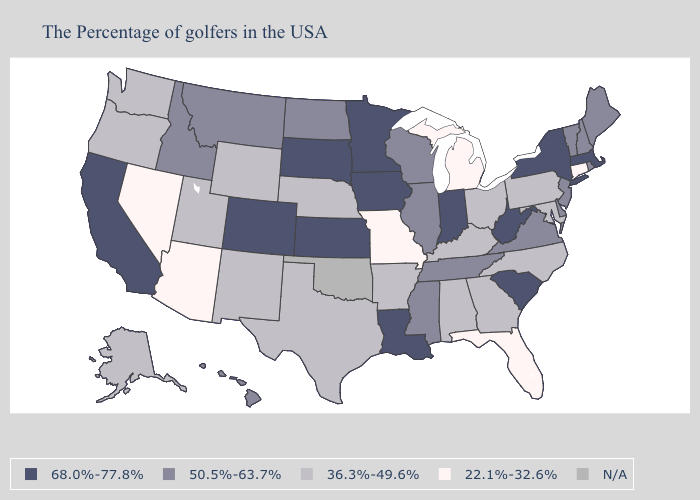Does New Mexico have the highest value in the USA?
Keep it brief. No. Does Vermont have the highest value in the Northeast?
Write a very short answer. No. Among the states that border Virginia , which have the highest value?
Quick response, please. West Virginia. Does the first symbol in the legend represent the smallest category?
Be succinct. No. What is the lowest value in the USA?
Be succinct. 22.1%-32.6%. What is the value of Wyoming?
Keep it brief. 36.3%-49.6%. Is the legend a continuous bar?
Short answer required. No. What is the lowest value in the USA?
Quick response, please. 22.1%-32.6%. How many symbols are there in the legend?
Short answer required. 5. What is the value of North Dakota?
Write a very short answer. 50.5%-63.7%. What is the value of North Dakota?
Be succinct. 50.5%-63.7%. Name the states that have a value in the range 68.0%-77.8%?
Short answer required. Massachusetts, New York, South Carolina, West Virginia, Indiana, Louisiana, Minnesota, Iowa, Kansas, South Dakota, Colorado, California. Does the map have missing data?
Be succinct. Yes. Name the states that have a value in the range 22.1%-32.6%?
Short answer required. Connecticut, Florida, Michigan, Missouri, Arizona, Nevada. 